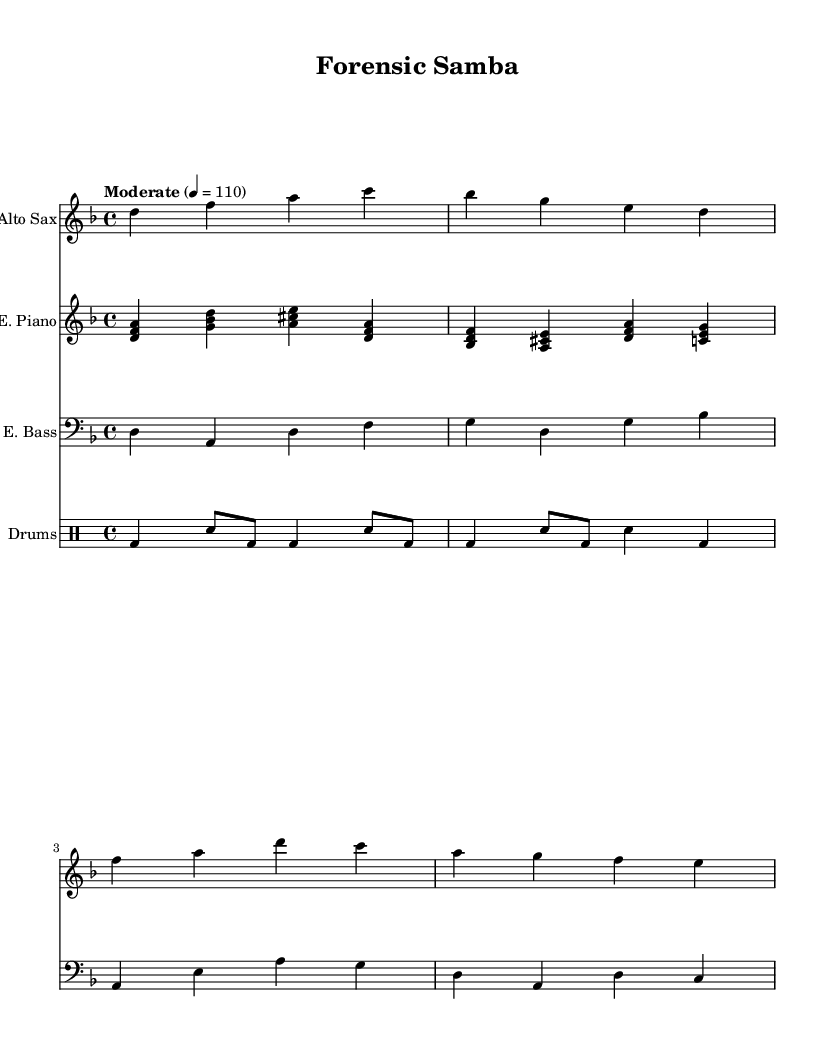What is the key signature of this music? The key signature is D minor, which has one flat. This can be identified by looking at the key signature section at the beginning of the staff, indicating the specific notes that will be lowered in pitch.
Answer: D minor What is the time signature of this music? The time signature is 4/4, which is indicatedby the fraction at the beginning of the score. The top number (4) indicates the number of beats per measure, and the bottom number (4) indicates that a quarter note receives one beat.
Answer: 4/4 What is the tempo marking for this piece? The tempo marking is "Moderate" with a metronome marking of 110 beats per minute. This is found above the staff, indicating how fast the music should be played.
Answer: Moderate, 110 How many instruments are featured in this piece? There are four instruments featured in the piece, which can be gathered from the score layout listing each distinct instrument part: Alto Sax, Electric Piano, Electric Bass, and Drums.
Answer: Four What kind of rhythm patterns can be identified from the drum part? The rhythm in the drum part consists of a combination of bass drum (bd) and snare (sn) with varied note lengths, which creates syncopated patterns typical in Latin music. This intricate relationship is evident when analyzing the measures for beat distribution.
Answer: Syncopated Which section features a chordal progression? The Electric Piano section showcases a chordal progression, evident from the simultaneous playing of multiple pitches that outline harmonies within the measures. This can be observed through closely looking at the groupings of notes played together.
Answer: Electric Piano What mood does the title "Forensic Samba" suggest for the piece? The title "Forensic Samba" suggests an intriguing mix of themes, blending the lively, rhythmic nature of samba with elements of investigation and analysis, which might hint at a combination of energetic and mysterious musical characteristics throughout the piece.
Answer: Energetic and mysterious 